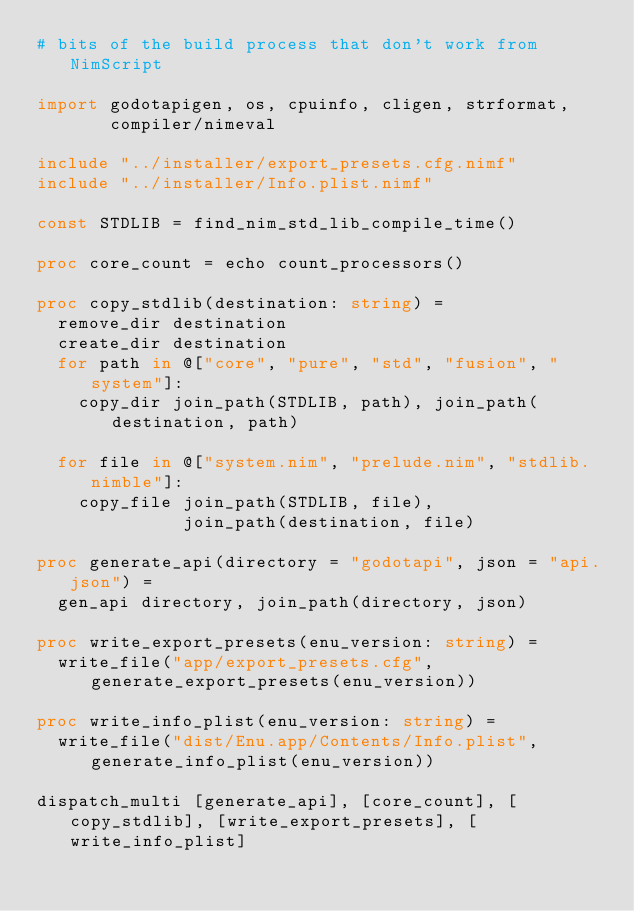Convert code to text. <code><loc_0><loc_0><loc_500><loc_500><_Nim_># bits of the build process that don't work from NimScript

import godotapigen, os, cpuinfo, cligen, strformat,
       compiler/nimeval

include "../installer/export_presets.cfg.nimf"
include "../installer/Info.plist.nimf"

const STDLIB = find_nim_std_lib_compile_time()

proc core_count = echo count_processors()

proc copy_stdlib(destination: string) =
  remove_dir destination
  create_dir destination
  for path in @["core", "pure", "std", "fusion", "system"]:
    copy_dir join_path(STDLIB, path), join_path(destination, path)

  for file in @["system.nim", "prelude.nim", "stdlib.nimble"]:
    copy_file join_path(STDLIB, file),
              join_path(destination, file)

proc generate_api(directory = "godotapi", json = "api.json") =
  gen_api directory, join_path(directory, json)

proc write_export_presets(enu_version: string) =
  write_file("app/export_presets.cfg", generate_export_presets(enu_version))

proc write_info_plist(enu_version: string) =
  write_file("dist/Enu.app/Contents/Info.plist", generate_info_plist(enu_version))

dispatch_multi [generate_api], [core_count], [copy_stdlib], [write_export_presets], [write_info_plist]
</code> 